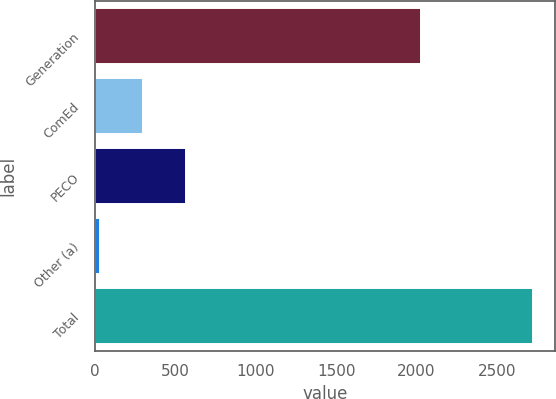Convert chart. <chart><loc_0><loc_0><loc_500><loc_500><bar_chart><fcel>Generation<fcel>ComEd<fcel>PECO<fcel>Other (a)<fcel>Total<nl><fcel>2025<fcel>298.7<fcel>568.4<fcel>29<fcel>2726<nl></chart> 